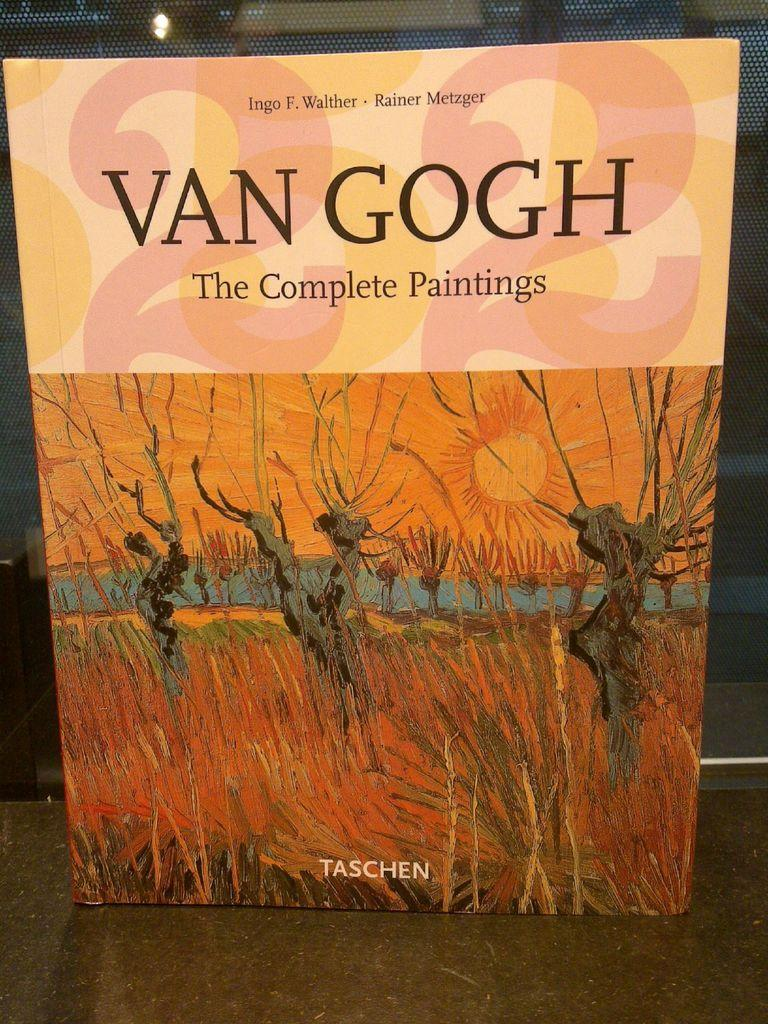<image>
Describe the image concisely. A book featuring the Complete Paintings of Van Gogh sits on display 